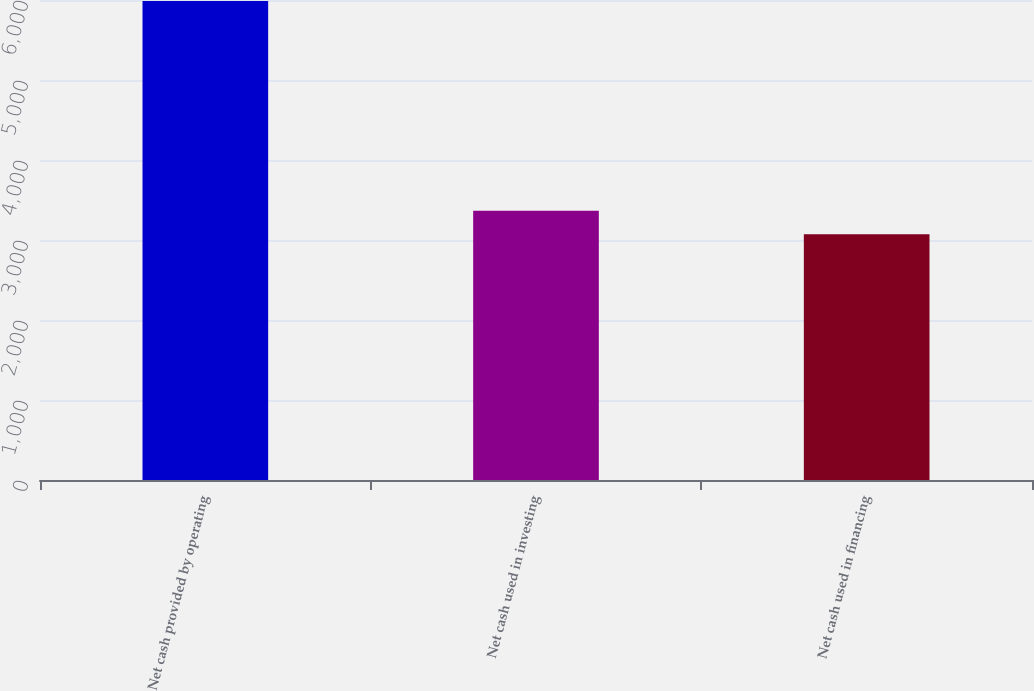Convert chart to OTSL. <chart><loc_0><loc_0><loc_500><loc_500><bar_chart><fcel>Net cash provided by operating<fcel>Net cash used in investing<fcel>Net cash used in financing<nl><fcel>5988<fcel>3364.5<fcel>3073<nl></chart> 